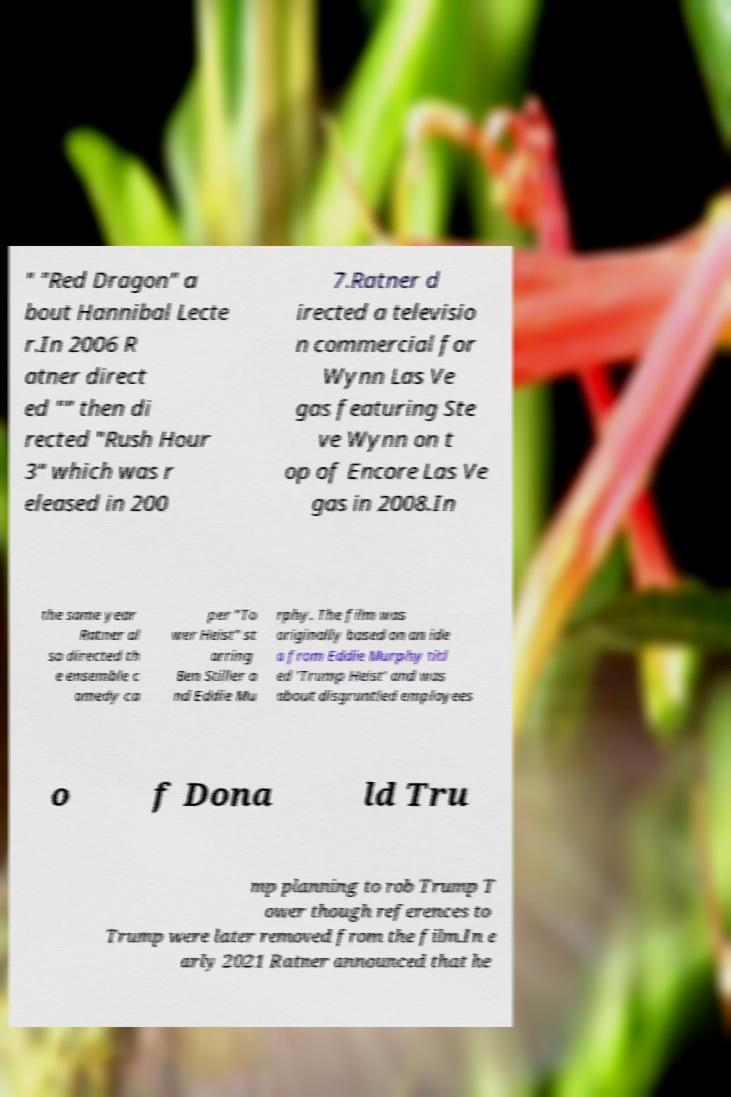Can you read and provide the text displayed in the image?This photo seems to have some interesting text. Can you extract and type it out for me? " "Red Dragon" a bout Hannibal Lecte r.In 2006 R atner direct ed "" then di rected "Rush Hour 3" which was r eleased in 200 7.Ratner d irected a televisio n commercial for Wynn Las Ve gas featuring Ste ve Wynn on t op of Encore Las Ve gas in 2008.In the same year Ratner al so directed th e ensemble c omedy ca per "To wer Heist" st arring Ben Stiller a nd Eddie Mu rphy. The film was originally based on an ide a from Eddie Murphy titl ed 'Trump Heist' and was about disgruntled employees o f Dona ld Tru mp planning to rob Trump T ower though references to Trump were later removed from the film.In e arly 2021 Ratner announced that he 